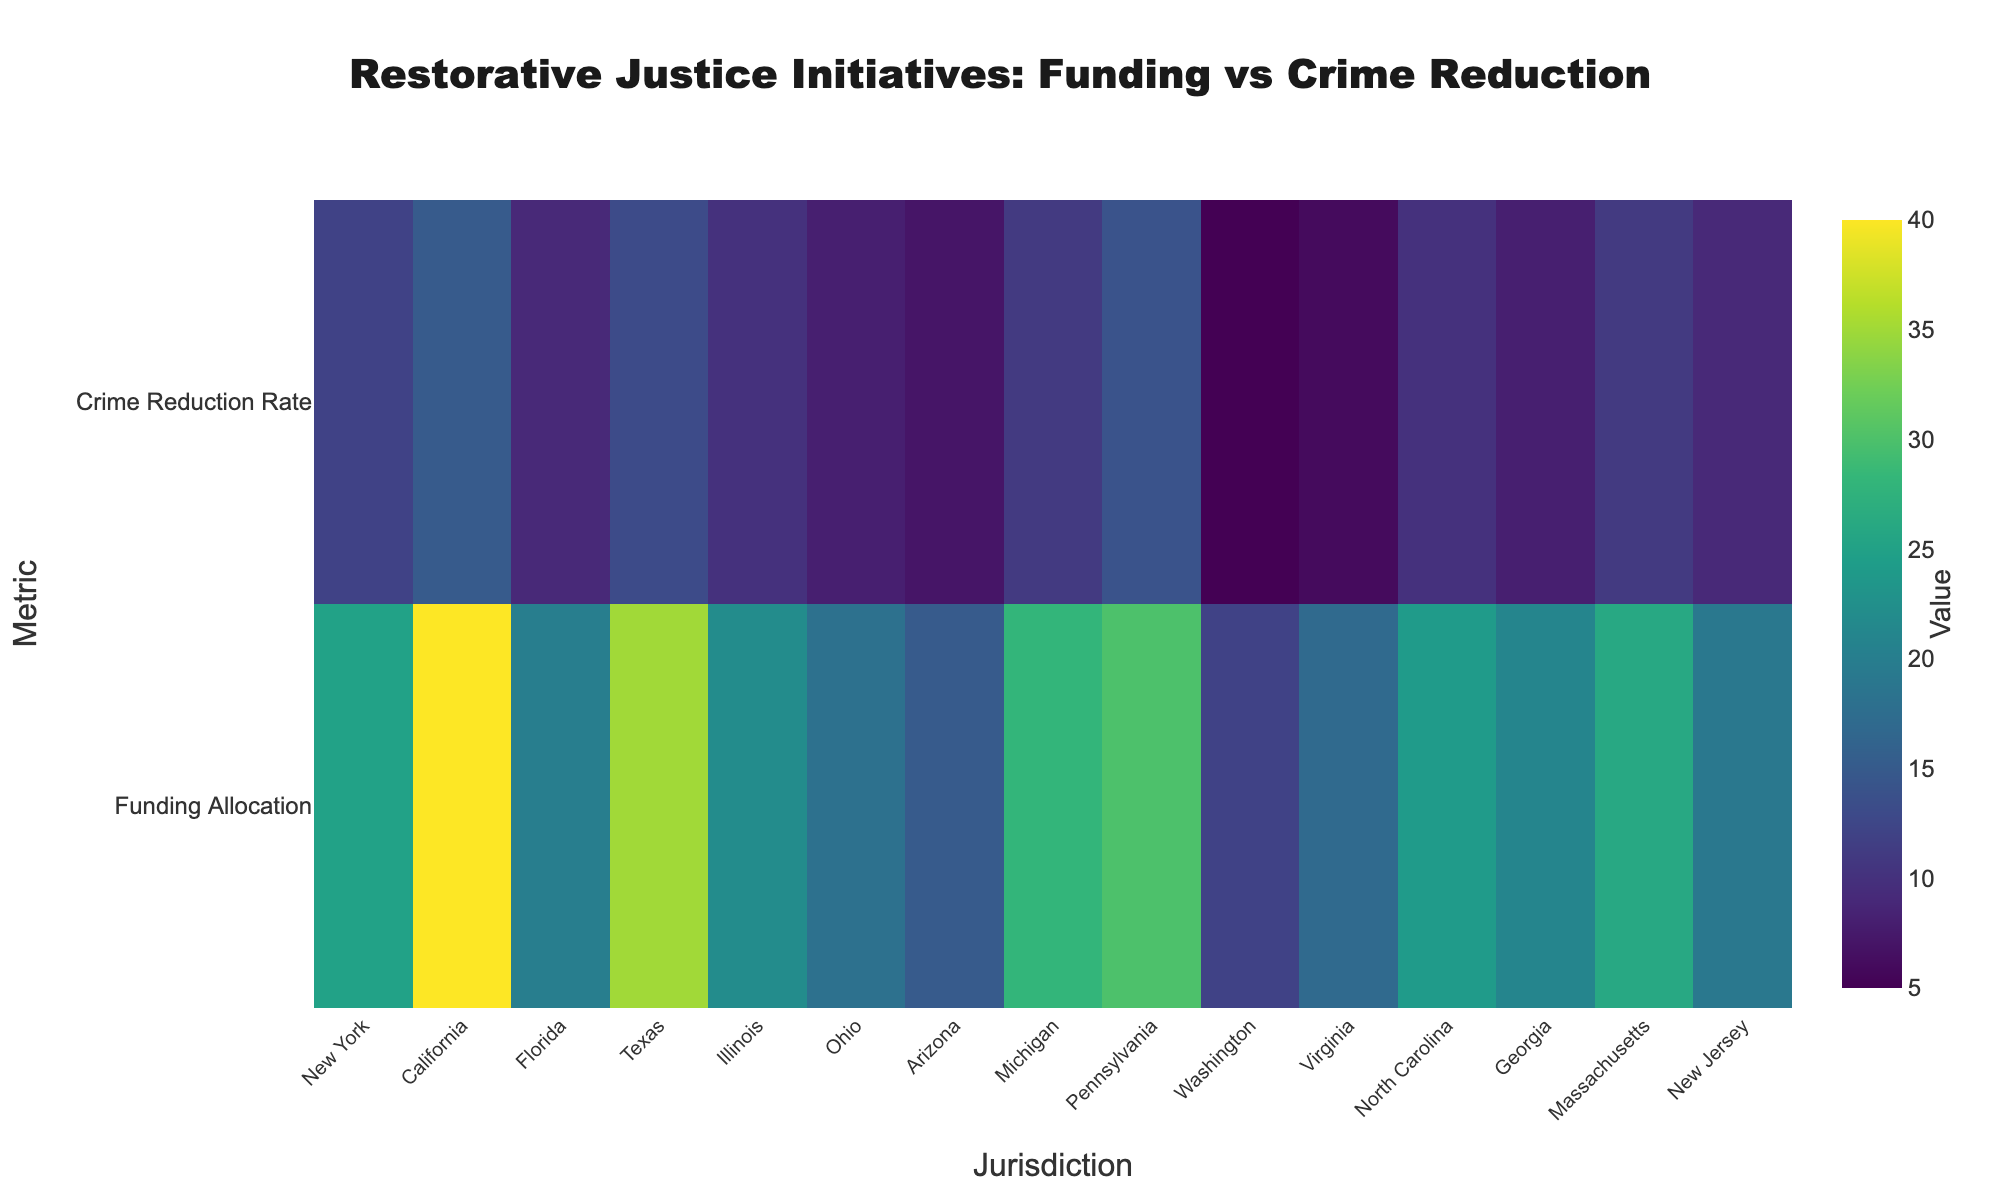What is the title of the heatmap? The title is printed at the top center of the heatmap. It is clearly stated, helping the viewer understand what the data represents immediately.
Answer: Restorative Justice Initiatives: Funding vs Crime Reduction Which jurisdiction has the highest funding allocation? By looking at the heatmap's color gradient and the labels under the 'Funding Allocation' row, we can identify the jurisdiction with the darkest color, which indicates the highest value.
Answer: California Between Funding Allocation and Crime Reduction Rate, which metric does Texas have a higher value in? Look at the heatmap for Texas and compare the color intensity between the 'Funding Allocation' and 'Crime Reduction Rate' rows. The row with the darker color represents the higher value.
Answer: Funding Allocation How does the Funding Allocation in Ohio compare to that in New Jersey? Compare the colors in the 'Funding Allocation' row for both Ohio and New Jersey. The row with the darker color has the higher funding allocation.
Answer: Higher in Ohio Which jurisdiction has the lowest Crime Reduction Rate? By checking the color gradient in the 'Crime Reduction Rate' row across all jurisdictions, the lightest color indicates the lowest value.
Answer: Washington What is the average Crime Reduction Rate across all jurisdictions? Sum the percentages of the Crime Reduction Rates for all jurisdictions and divide by the number of jurisdictions. Calculation: (12 + 15 + 9 + 13 + 10 + 8 + 7 + 11 + 14 + 5 + 6 + 10 + 8 + 11 + 9) / 15 = 10
Answer: 10 Do any jurisdictions have the same Funding Allocation and if so, which ones? Compare the colors in the 'Funding Allocation' row for all jurisdictions. Look for identical colors which indicate the same funding allocation values.
Answer: None Which jurisdictions have a Funding Allocation of more than 30 million USD but crime reduction rate below 15%? First identify jurisdictions with funding allocations above 30 million USD, then among those, find which have crime reduction rates below 15% by checking the corresponding colors.
Answer: California, Texas, Pennsylvania How many jurisdictions have a Funding Allocation below 20 million USD? Count the number of jurisdictions whose colors in the 'Funding Allocation' row indicate values below 20 million USD.
Answer: Four (Ohio, Arizona, Washington, Virginia) Which jurisdiction shows the highest discrepancy between Funding Allocation and Crime Reduction Rate? Calculate the discrepancy for each jurisdiction by taking the absolute difference between the Funding Allocation and Crime Reduction Rate values, then compare all discrepancies to determine the highest one.
Answer: Washington 